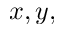Convert formula to latex. <formula><loc_0><loc_0><loc_500><loc_500>x , y ,</formula> 